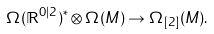<formula> <loc_0><loc_0><loc_500><loc_500>\Omega ( \mathbb { R } ^ { 0 | 2 } ) ^ { * } \otimes \Omega ( M ) \rightarrow \Omega _ { [ 2 ] } ( M ) .</formula> 